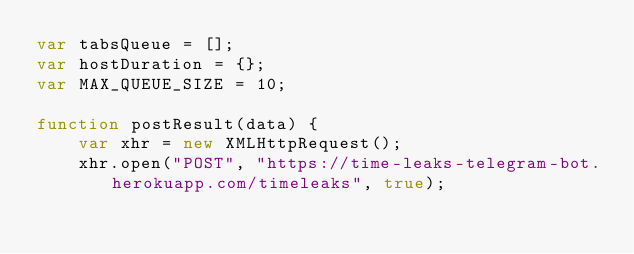<code> <loc_0><loc_0><loc_500><loc_500><_JavaScript_>var tabsQueue = [];
var hostDuration = {};
var MAX_QUEUE_SIZE = 10;

function postResult(data) {
    var xhr = new XMLHttpRequest();	
    xhr.open("POST", "https://time-leaks-telegram-bot.herokuapp.com/timeleaks", true);</code> 